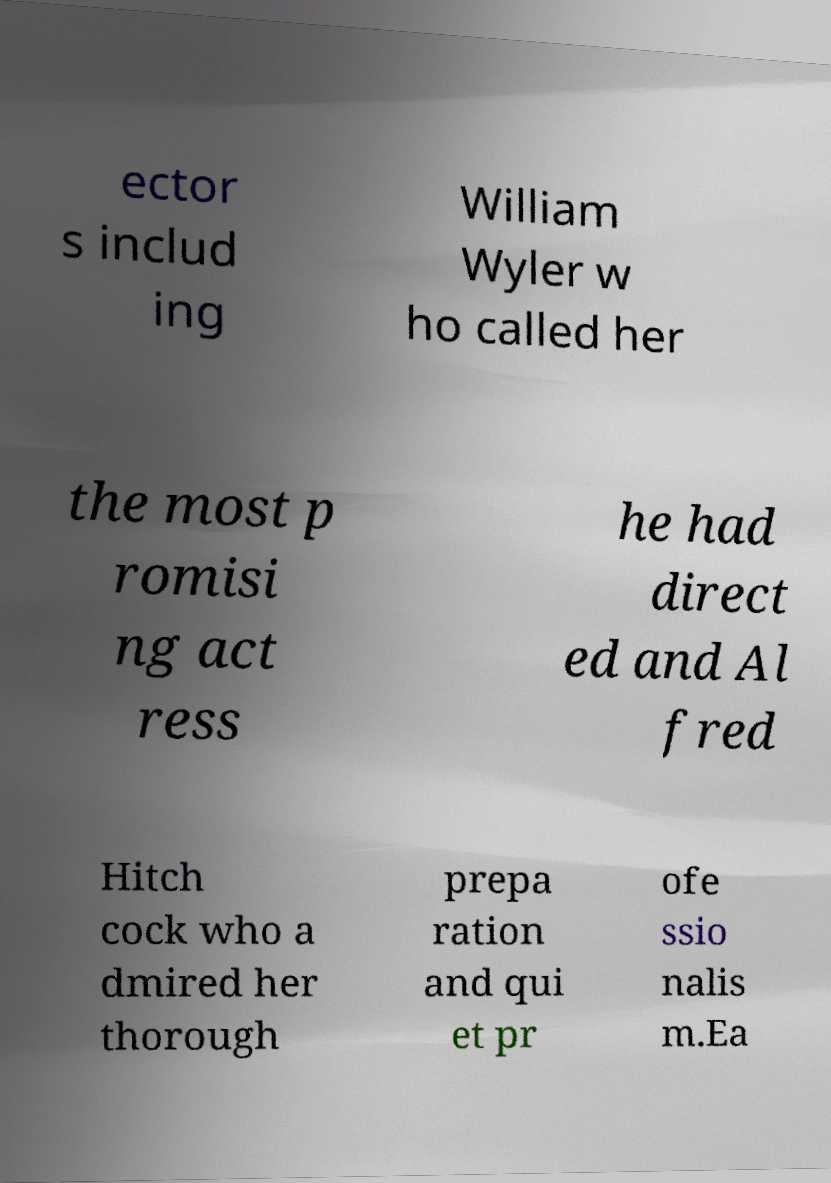Can you accurately transcribe the text from the provided image for me? ector s includ ing William Wyler w ho called her the most p romisi ng act ress he had direct ed and Al fred Hitch cock who a dmired her thorough prepa ration and qui et pr ofe ssio nalis m.Ea 